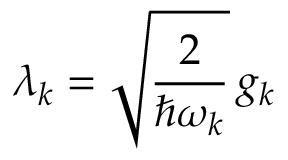Convert formula to latex. <formula><loc_0><loc_0><loc_500><loc_500>\lambda _ { k } = \sqrt { \frac { 2 } { \hbar { \omega } _ { k } } } \, g _ { k }</formula> 